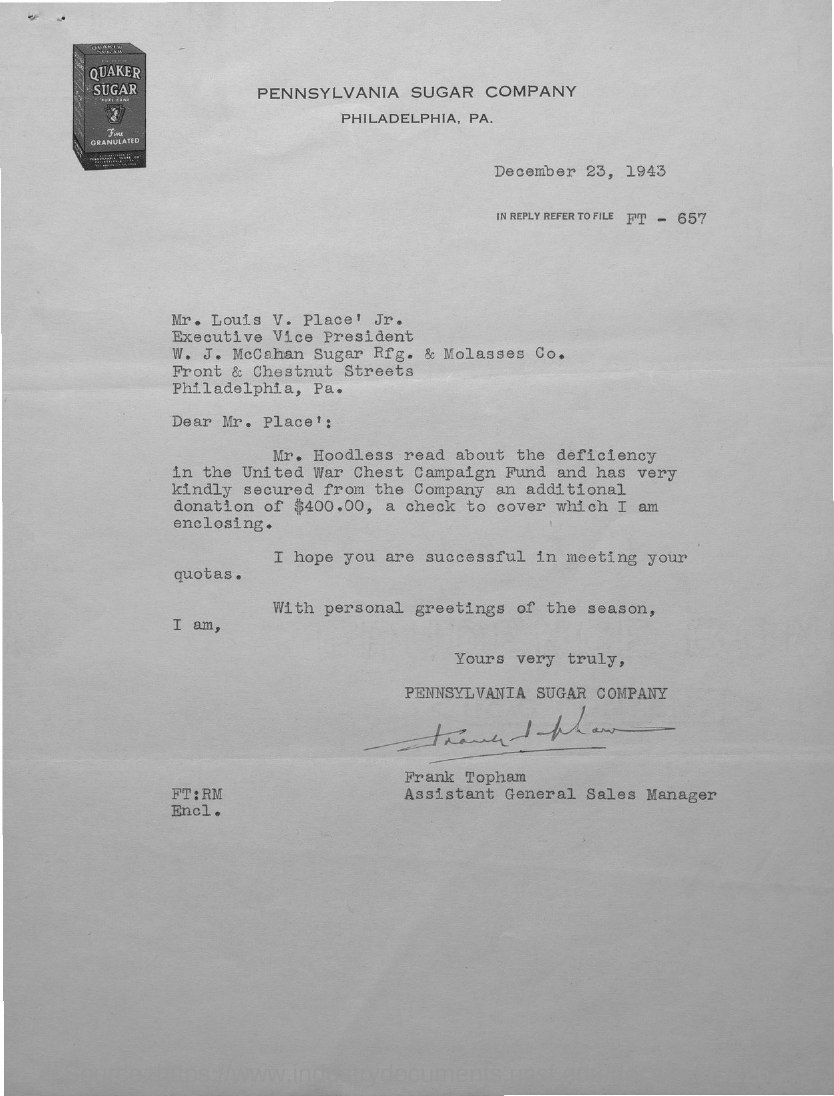List a handful of essential elements in this visual. The issued date of this letter is December 23, 1943. Please refer to file FT-657 in your response. Mr. Louis V. Place, Jr. holds the designation of Executive Vice President. Frank Topham holds the position of Assistant General Sales Manager. The Pennsylvania Sugar Company is mentioned in the letterhead. 